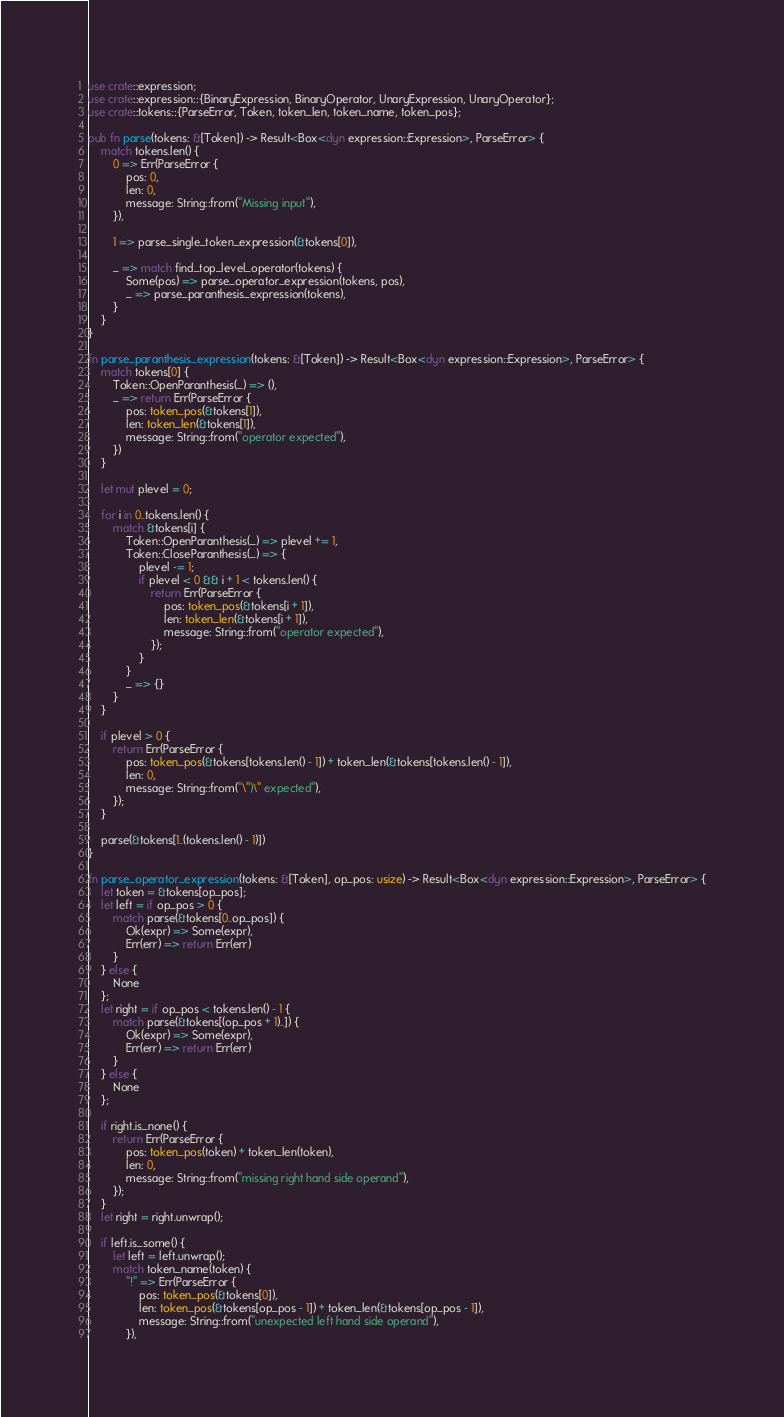Convert code to text. <code><loc_0><loc_0><loc_500><loc_500><_Rust_>use crate::expression;
use crate::expression::{BinaryExpression, BinaryOperator, UnaryExpression, UnaryOperator};
use crate::tokens::{ParseError, Token, token_len, token_name, token_pos};

pub fn parse(tokens: &[Token]) -> Result<Box<dyn expression::Expression>, ParseError> {
    match tokens.len() {
        0 => Err(ParseError {
            pos: 0,
            len: 0,
            message: String::from("Missing input"),
        }),

        1 => parse_single_token_expression(&tokens[0]),

        _ => match find_top_level_operator(tokens) {
            Some(pos) => parse_operator_expression(tokens, pos),
            _ => parse_paranthesis_expression(tokens),
        }
    }
}

fn parse_paranthesis_expression(tokens: &[Token]) -> Result<Box<dyn expression::Expression>, ParseError> {
    match tokens[0] {
        Token::OpenParanthesis(_) => (),
        _ => return Err(ParseError {
            pos: token_pos(&tokens[1]),
            len: token_len(&tokens[1]),
            message: String::from("operator expected"),
        })
    }

    let mut plevel = 0;

    for i in 0..tokens.len() {
        match &tokens[i] {
            Token::OpenParanthesis(_) => plevel += 1,
            Token::CloseParanthesis(_) => {
                plevel -= 1;
                if plevel < 0 && i + 1 < tokens.len() {
                    return Err(ParseError {
                        pos: token_pos(&tokens[i + 1]),
                        len: token_len(&tokens[i + 1]),
                        message: String::from("operator expected"),
                    });
                }
            }
            _ => {}
        }
    }

    if plevel > 0 {
        return Err(ParseError {
            pos: token_pos(&tokens[tokens.len() - 1]) + token_len(&tokens[tokens.len() - 1]),
            len: 0,
            message: String::from("\")\" expected"),
        });
    }

    parse(&tokens[1..(tokens.len() - 1)])
}

fn parse_operator_expression(tokens: &[Token], op_pos: usize) -> Result<Box<dyn expression::Expression>, ParseError> {
    let token = &tokens[op_pos];
    let left = if op_pos > 0 {
        match parse(&tokens[0..op_pos]) {
            Ok(expr) => Some(expr),
            Err(err) => return Err(err)
        }
    } else {
        None
    };
    let right = if op_pos < tokens.len() - 1 {
        match parse(&tokens[(op_pos + 1)..]) {
            Ok(expr) => Some(expr),
            Err(err) => return Err(err)
        }
    } else {
        None
    };

    if right.is_none() {
        return Err(ParseError {
            pos: token_pos(token) + token_len(token),
            len: 0,
            message: String::from("missing right hand side operand"),
        });
    }
    let right = right.unwrap();

    if left.is_some() {
        let left = left.unwrap();
        match token_name(token) {
            "!" => Err(ParseError {
                pos: token_pos(&tokens[0]),
                len: token_pos(&tokens[op_pos - 1]) + token_len(&tokens[op_pos - 1]),
                message: String::from("unexpected left hand side operand"),
            }),</code> 